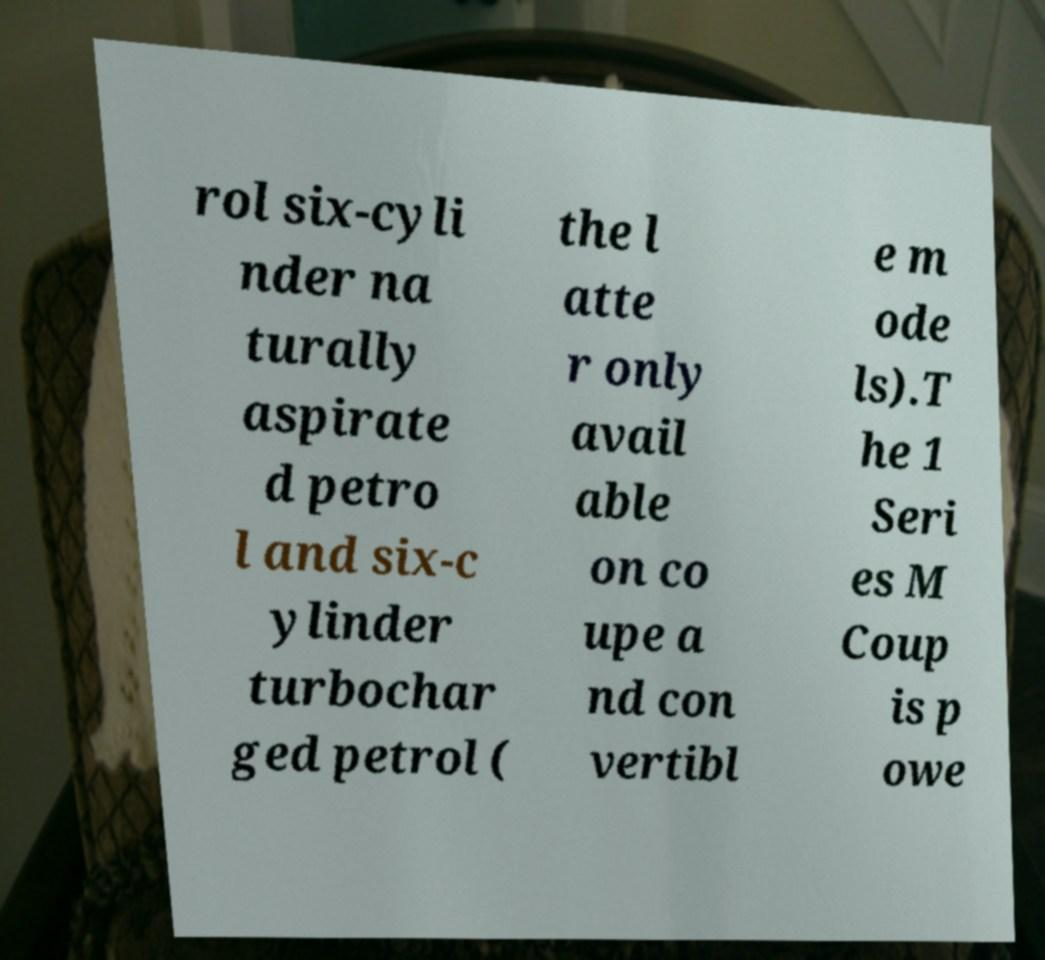Could you extract and type out the text from this image? rol six-cyli nder na turally aspirate d petro l and six-c ylinder turbochar ged petrol ( the l atte r only avail able on co upe a nd con vertibl e m ode ls).T he 1 Seri es M Coup is p owe 